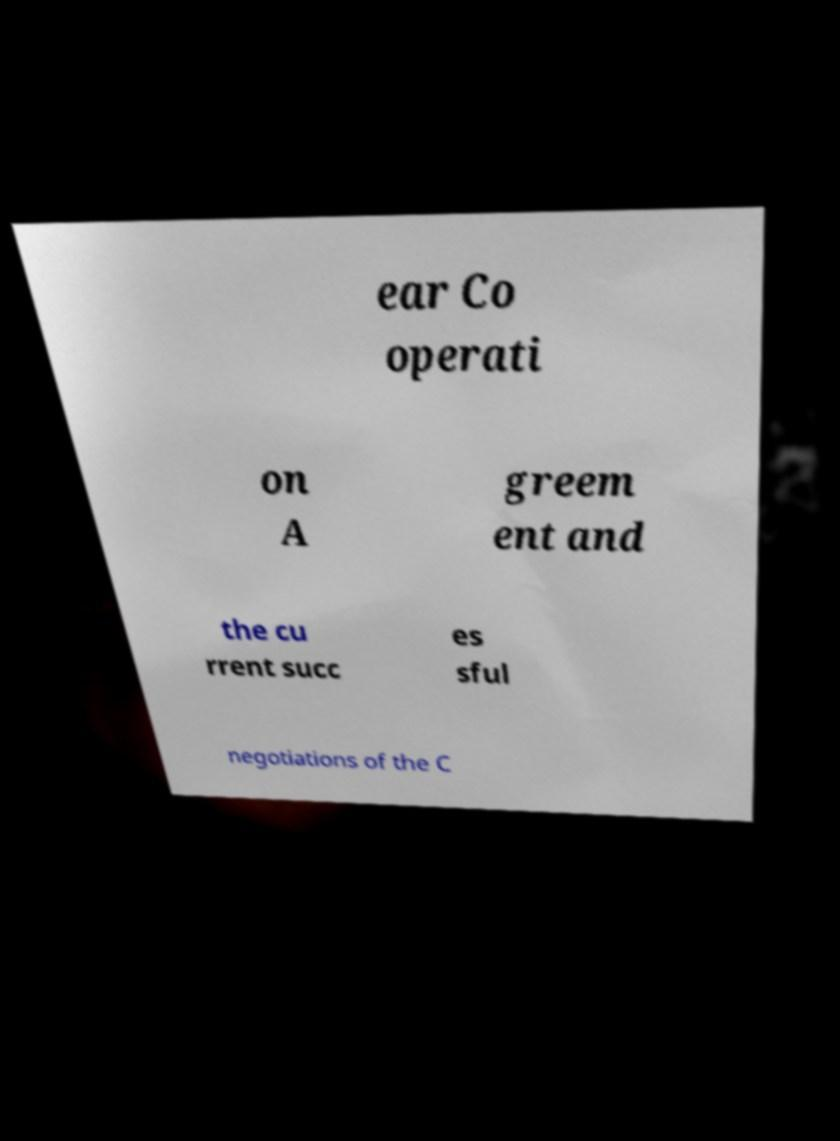Please read and relay the text visible in this image. What does it say? ear Co operati on A greem ent and the cu rrent succ es sful negotiations of the C 